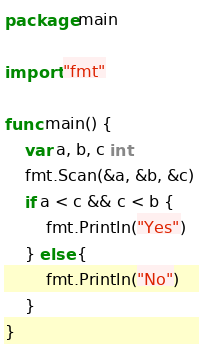Convert code to text. <code><loc_0><loc_0><loc_500><loc_500><_Go_>package main

import "fmt"

func main() {
	var a, b, c int
	fmt.Scan(&a, &b, &c)
	if a < c && c < b {
		fmt.Println("Yes")
	} else {
		fmt.Println("No")
	}
}
</code> 